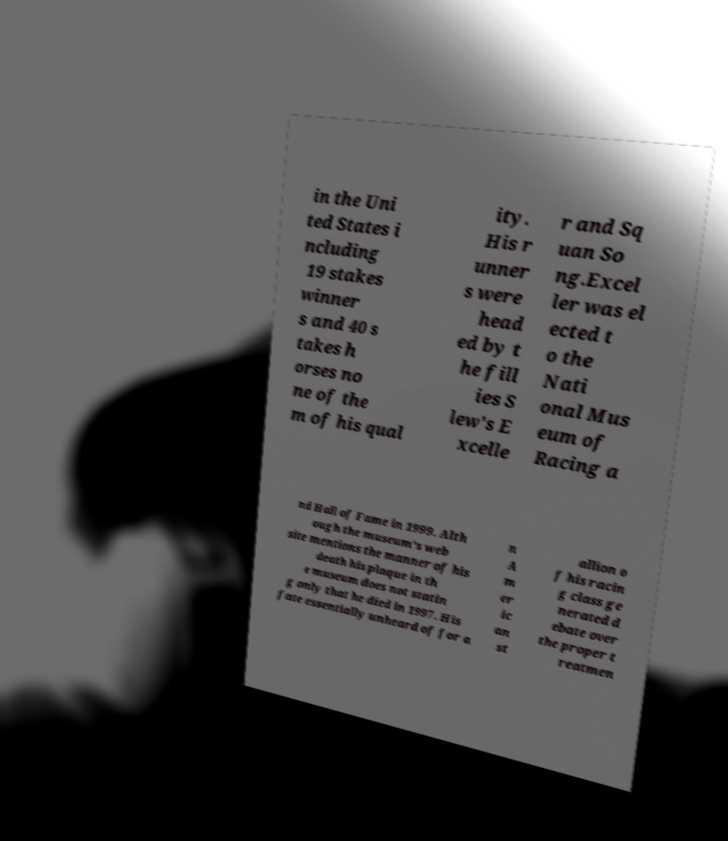What messages or text are displayed in this image? I need them in a readable, typed format. in the Uni ted States i ncluding 19 stakes winner s and 40 s takes h orses no ne of the m of his qual ity. His r unner s were head ed by t he fill ies S lew's E xcelle r and Sq uan So ng.Excel ler was el ected t o the Nati onal Mus eum of Racing a nd Hall of Fame in 1999. Alth ough the museum's web site mentions the manner of his death his plaque in th e museum does not statin g only that he died in 1997. His fate essentially unheard of for a n A m er ic an st allion o f his racin g class ge nerated d ebate over the proper t reatmen 